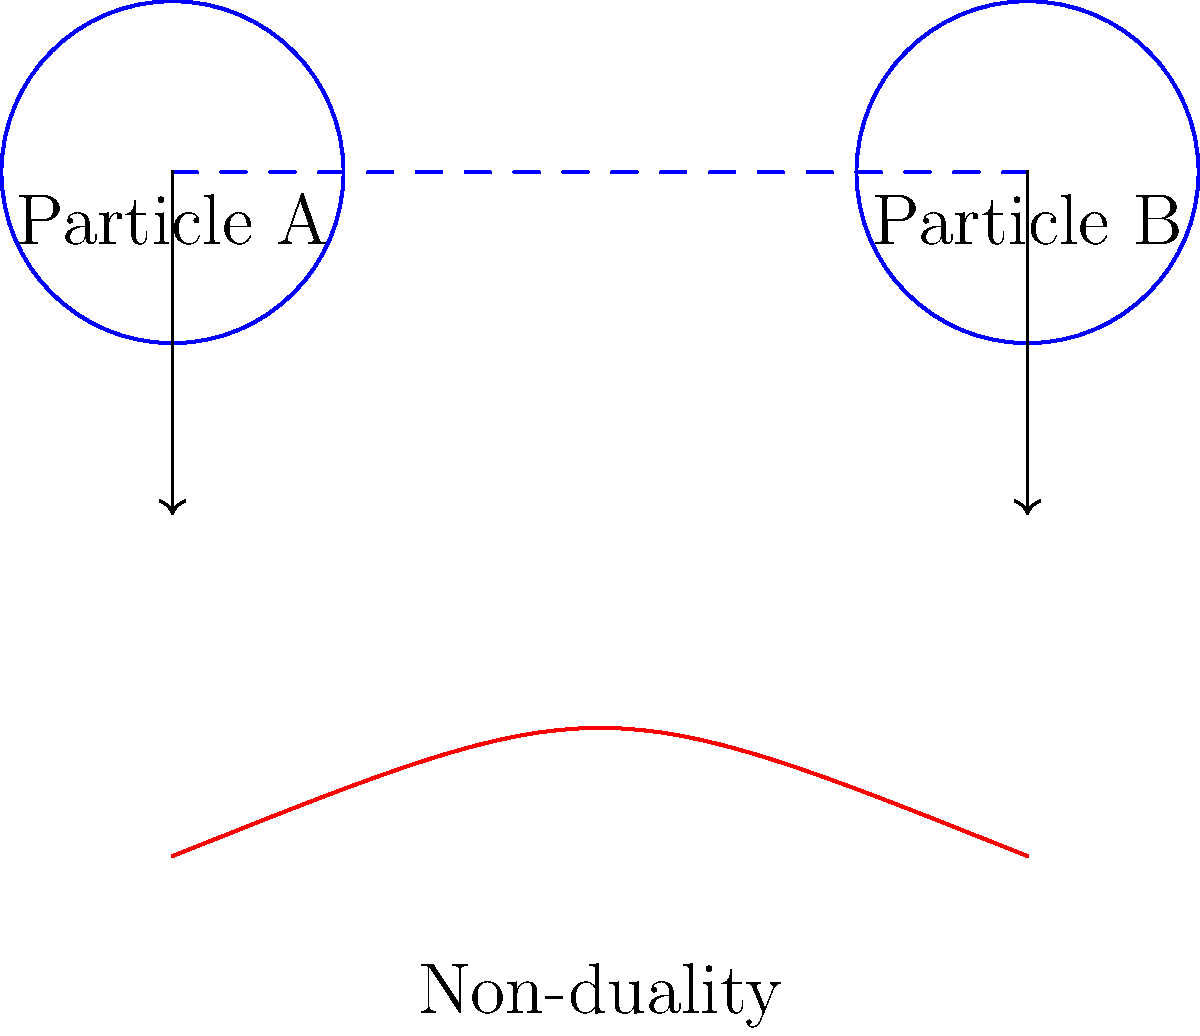In the diagram above, how does the representation of quantum entanglement (top) relate to the Buddhist concept of non-duality (bottom)? 1. Quantum entanglement (top):
   - Two particles (A and B) are shown connected by a dashed line.
   - This represents their interconnected state, where measuring one instantly affects the other, regardless of distance.

2. Buddhist non-duality (bottom):
   - A single curved line represents the concept of non-duality.
   - This illustrates the interconnectedness of all phenomena and the lack of separation between subject and object.

3. Relationship between the concepts:
   - Both representations show interconnectedness and inseparability.
   - Quantum entanglement demonstrates that particles can be intimately connected at a fundamental level.
   - Non-duality in Buddhism teaches that all things are inherently interconnected and lack independent existence.

4. Parallels:
   - Both challenge the notion of separate, independent entities.
   - They suggest a deeper, underlying unity in the nature of reality.
   - The instantaneous connection in quantum entanglement mirrors the Buddhist idea of interdependence.

5. Significance:
   - This parallel illustrates how modern scientific discoveries can align with ancient spiritual wisdom.
   - It suggests that both science and spirituality may be approaching similar truths about the nature of reality from different perspectives.
Answer: Both illustrate fundamental interconnectedness and challenge the notion of separate, independent entities. 